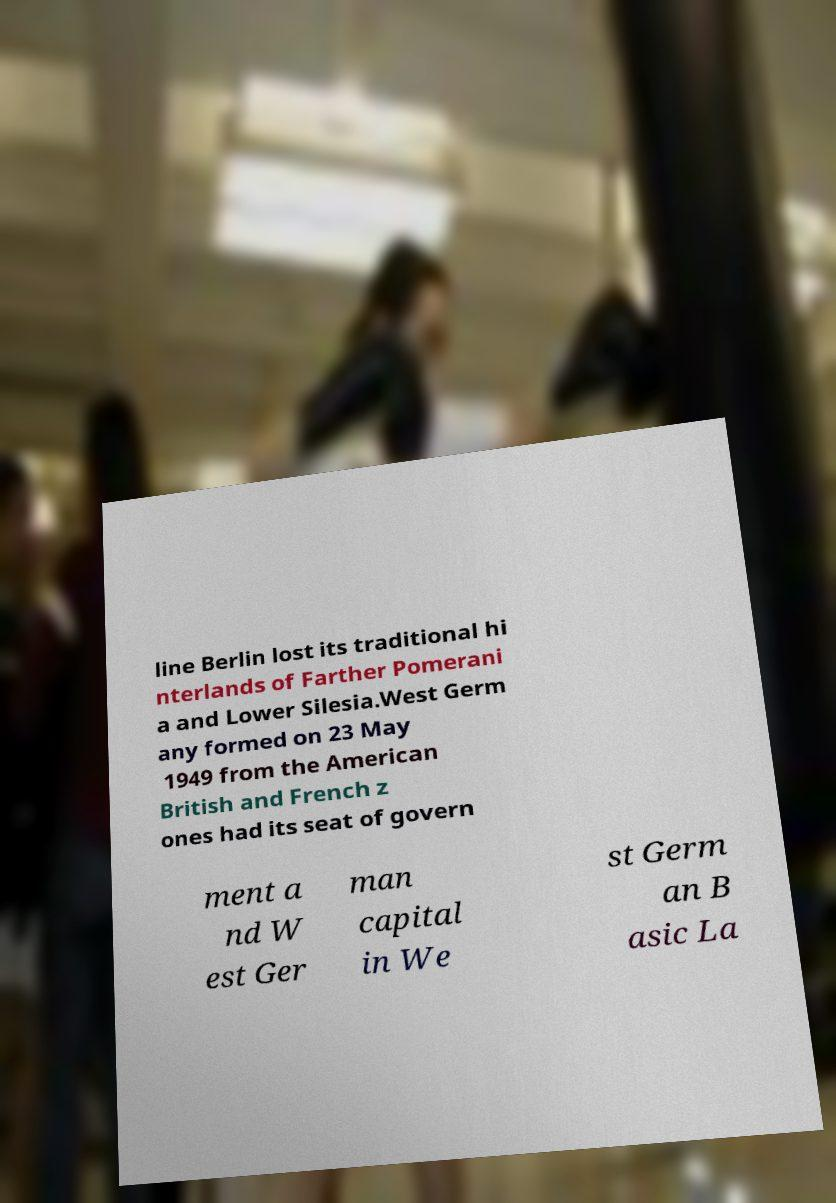What messages or text are displayed in this image? I need them in a readable, typed format. line Berlin lost its traditional hi nterlands of Farther Pomerani a and Lower Silesia.West Germ any formed on 23 May 1949 from the American British and French z ones had its seat of govern ment a nd W est Ger man capital in We st Germ an B asic La 